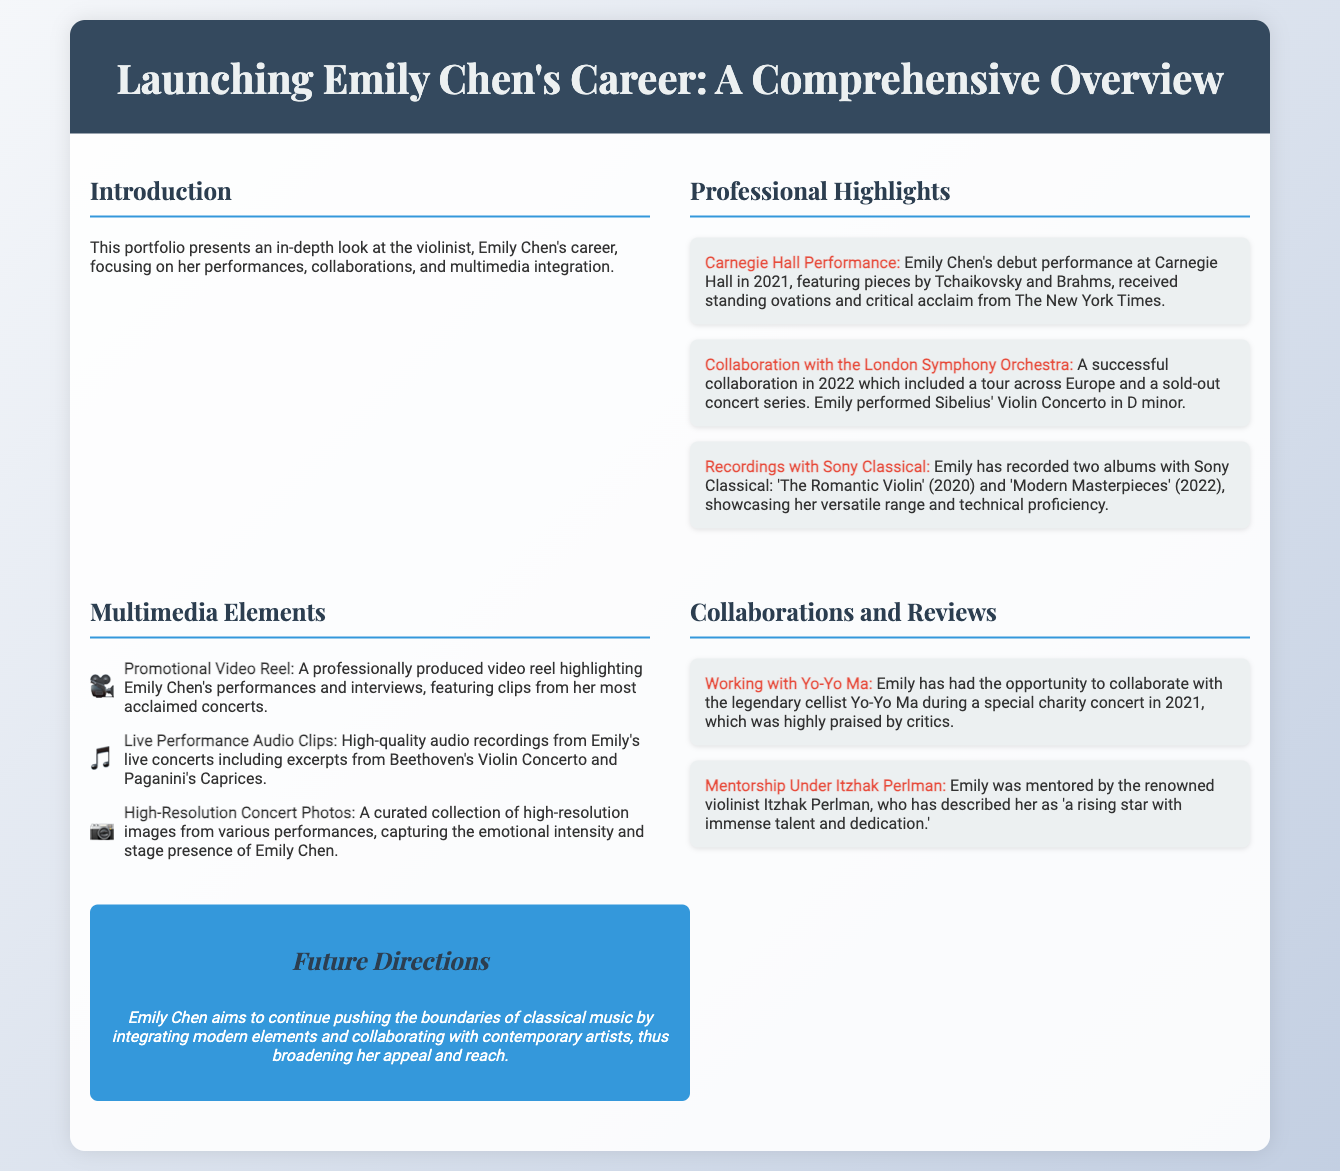What was Emily Chen's debut performance venue? The document states that Emily Chen's debut performance was at Carnegie Hall.
Answer: Carnegie Hall In what year did Emily perform with the London Symphony Orchestra? The collaboration with the London Symphony Orchestra occurred in 2022.
Answer: 2022 What are the titles of Emily Chen's albums recorded with Sony Classical? The document lists two albums: 'The Romantic Violin' and 'Modern Masterpieces'.
Answer: 'The Romantic Violin' and 'Modern Masterpieces' Who did Emily collaborate with during the charity concert in 2021? The document mentions her collaboration with Yo-Yo Ma at the charity concert.
Answer: Yo-Yo Ma What type of multimedia element is a promotional video reel? The promotional video reel includes highlights of Emily Chen's performances and interviews.
Answer: Highlighting performances and interviews Which prestigious violinist mentored Emily Chen? Itzhak Perlman is mentioned as Emily's mentor in the document.
Answer: Itzhak Perlman What is Emily Chen’s goal for the future of her musical career? The document states that Emily aims to integrate modern elements into classical music.
Answer: Integrating modern elements into classical music What piece did Emily perform in her collaboration with the London Symphony Orchestra? The document specifies that she performed Sibelius' Violin Concerto in D minor.
Answer: Sibelius' Violin Concerto in D minor 